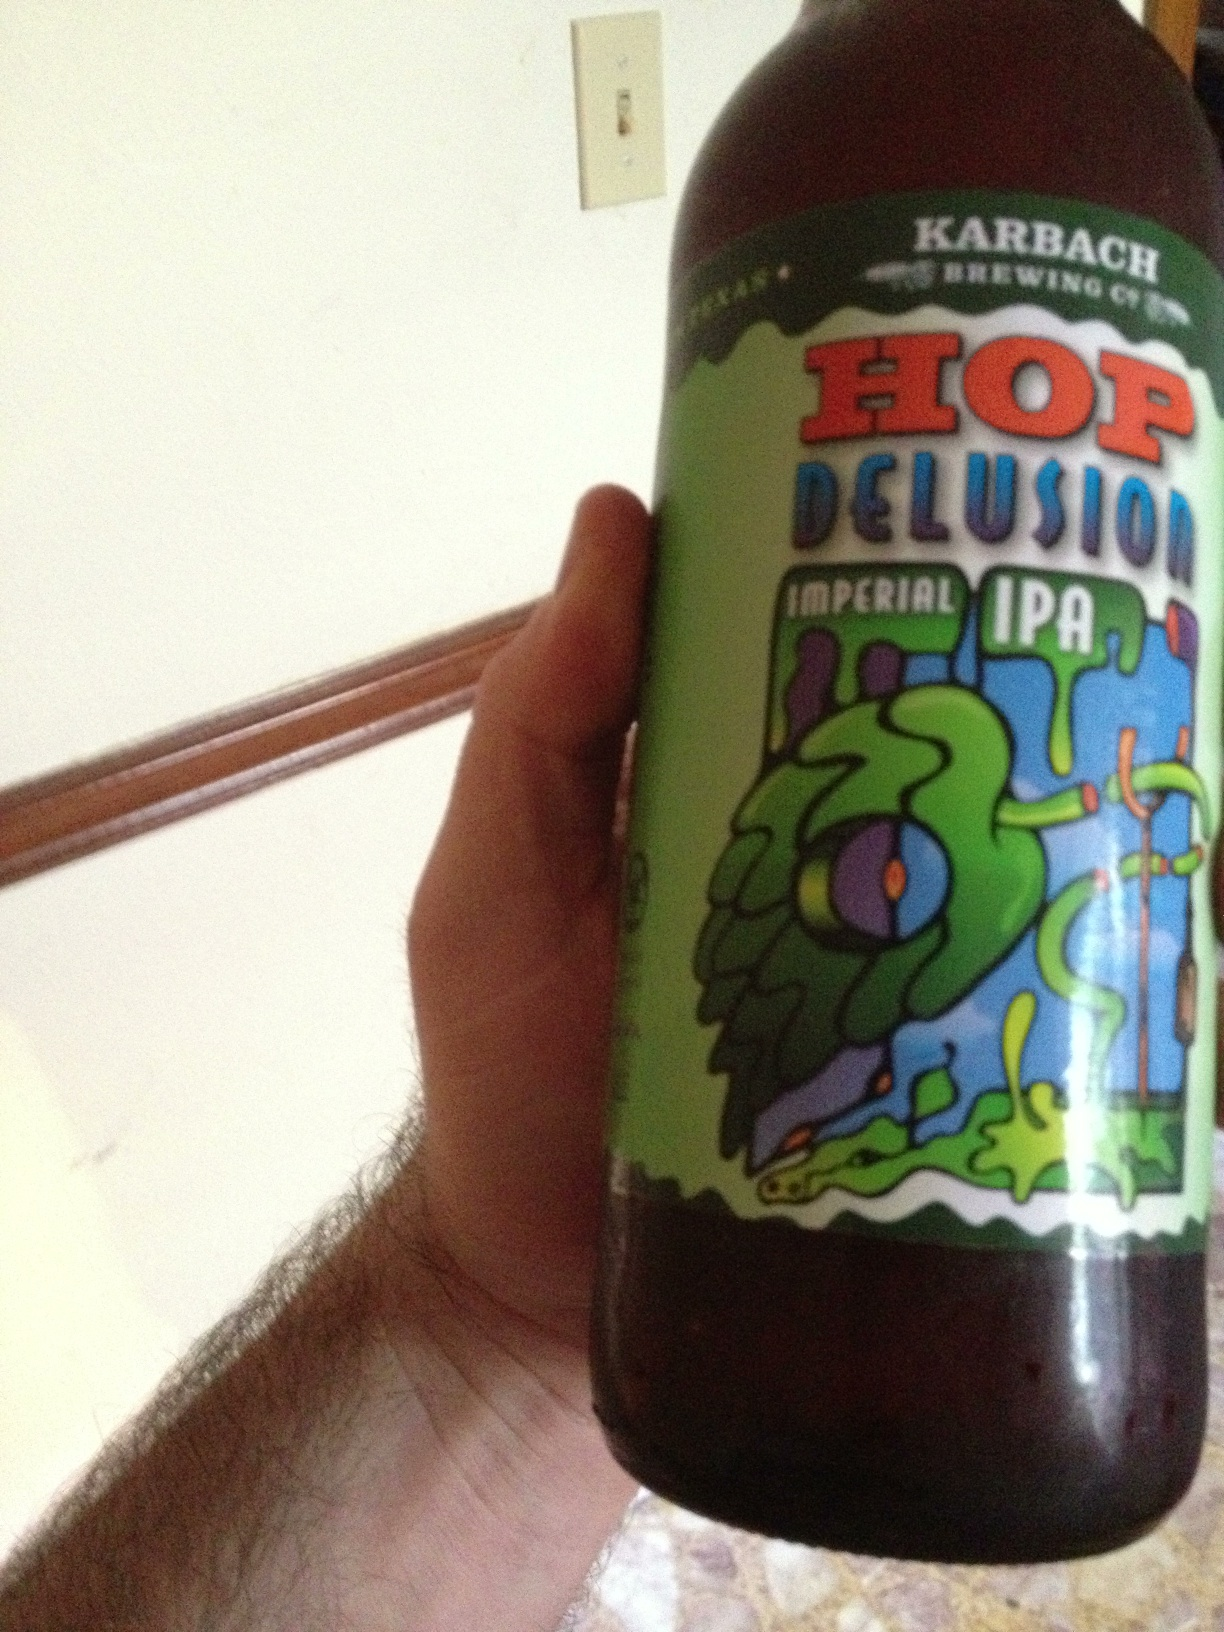Can you provide a brief history of Karbach Brewing Co.? Karbach Brewing Co. was founded in 2011 in Houston, Texas. Known for their innovative and high-quality craft beers, they have quickly become a beloved name in the craft beer community. The brewery is named after the Karbach Street in Houston, where their brewery is located. 